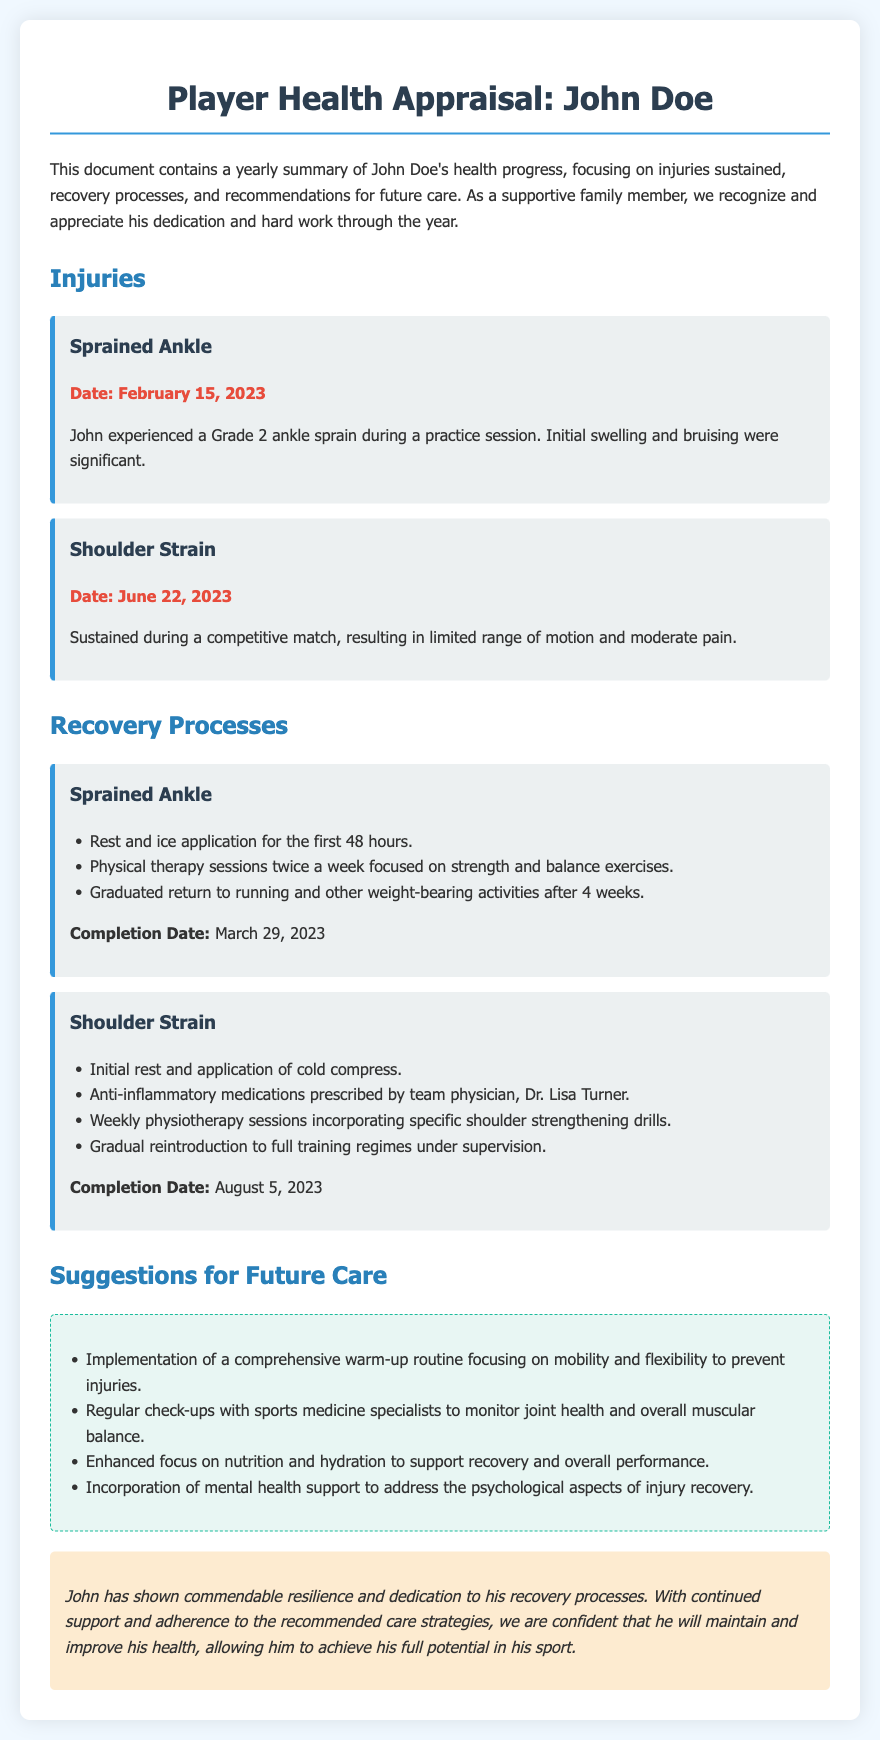What is the name of the player? The document introduces the player as John Doe.
Answer: John Doe What injury did John sustain on February 15, 2023? The document specifies that John experienced a Grade 2 ankle sprain on this date.
Answer: Sprained Ankle What is the completion date for the shoulder strain recovery? According to the document, the recovery from the shoulder strain was completed on August 5, 2023.
Answer: August 5, 2023 How many physiotherapy sessions did John attend for the shoulder strain? The document states that he had weekly physiotherapy sessions, but does not specify the total number.
Answer: Weekly sessions What is one suggestion for future care mentioned in the document? Several suggestions are listed, including the implementation of a comprehensive warm-up routine.
Answer: Comprehensive warm-up routine Who prescribed the anti-inflammatory medications for John? The document mentions that Dr. Lisa Turner prescribed the medication.
Answer: Dr. Lisa Turner What was the focus of the physical therapy for the sprained ankle? The physical therapy sessions focused on strength and balance exercises.
Answer: Strength and balance exercises What kind of support is suggested for mental health in the future care section? The document suggests incorporating mental health support to address recovery aspects.
Answer: Mental health support 